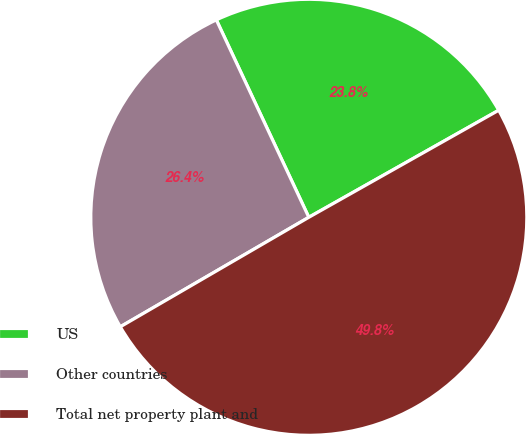Convert chart. <chart><loc_0><loc_0><loc_500><loc_500><pie_chart><fcel>US<fcel>Other countries<fcel>Total net property plant and<nl><fcel>23.8%<fcel>26.4%<fcel>49.79%<nl></chart> 